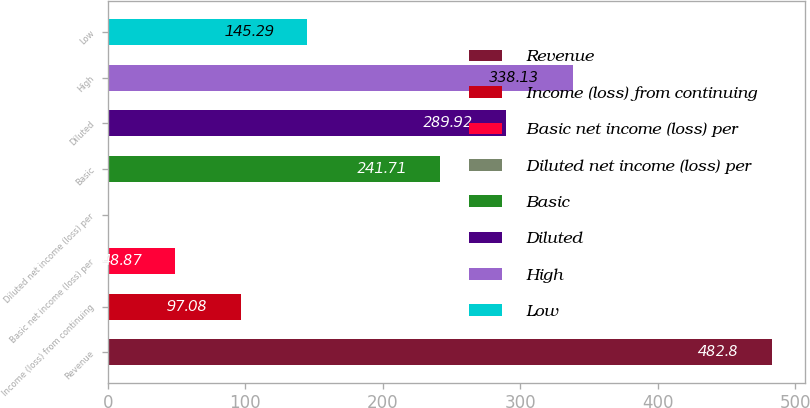Convert chart. <chart><loc_0><loc_0><loc_500><loc_500><bar_chart><fcel>Revenue<fcel>Income (loss) from continuing<fcel>Basic net income (loss) per<fcel>Diluted net income (loss) per<fcel>Basic<fcel>Diluted<fcel>High<fcel>Low<nl><fcel>482.8<fcel>97.08<fcel>48.87<fcel>0.66<fcel>241.71<fcel>289.92<fcel>338.13<fcel>145.29<nl></chart> 